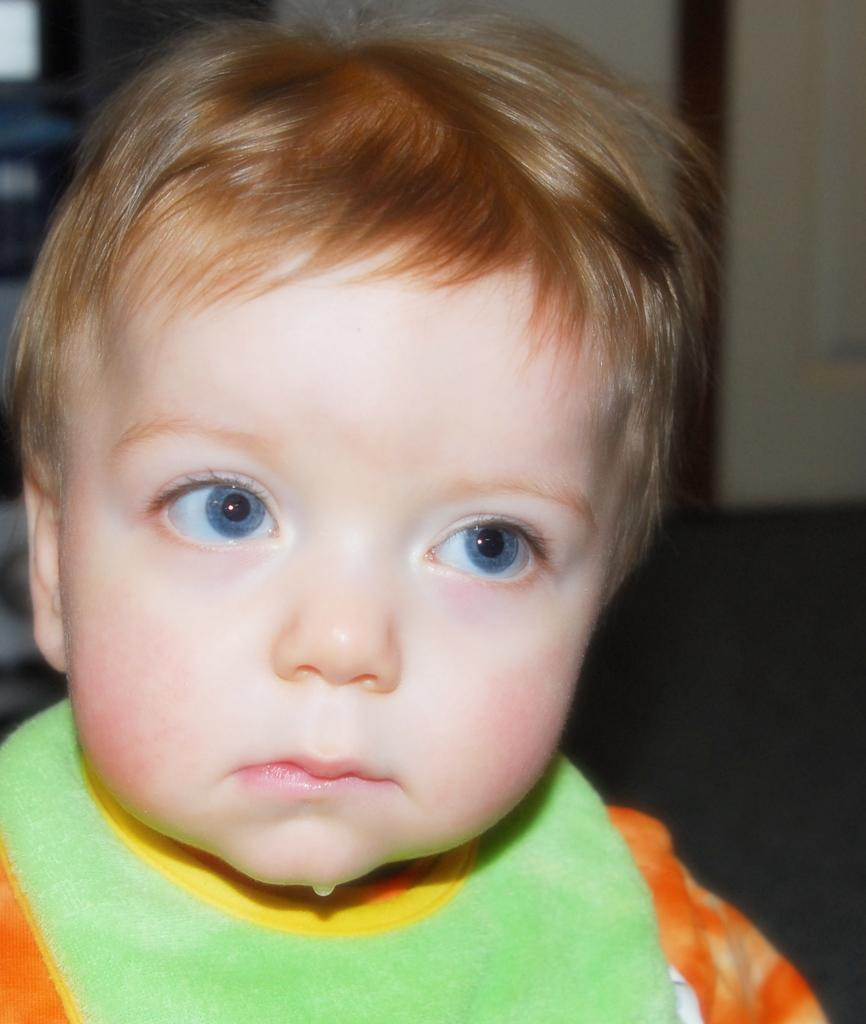What is the main subject of the image? There is a kid in the image. Can you describe the background of the image? The background of the image is blurred. What else can be seen in the background besides the blurred area? There are objects visible in the background. What surface is the kid standing on in the image? There is a floor visible in the image. How many arches can be seen supporting the houses in the image? There are no arches or houses present in the image. What type of beam is holding up the ceiling in the image? There is no ceiling or beam present in the image. 